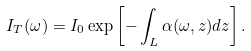Convert formula to latex. <formula><loc_0><loc_0><loc_500><loc_500>I _ { T } ( \omega ) = I _ { 0 } \exp \left [ - \int _ { L } \alpha ( \omega , z ) d z \right ] .</formula> 